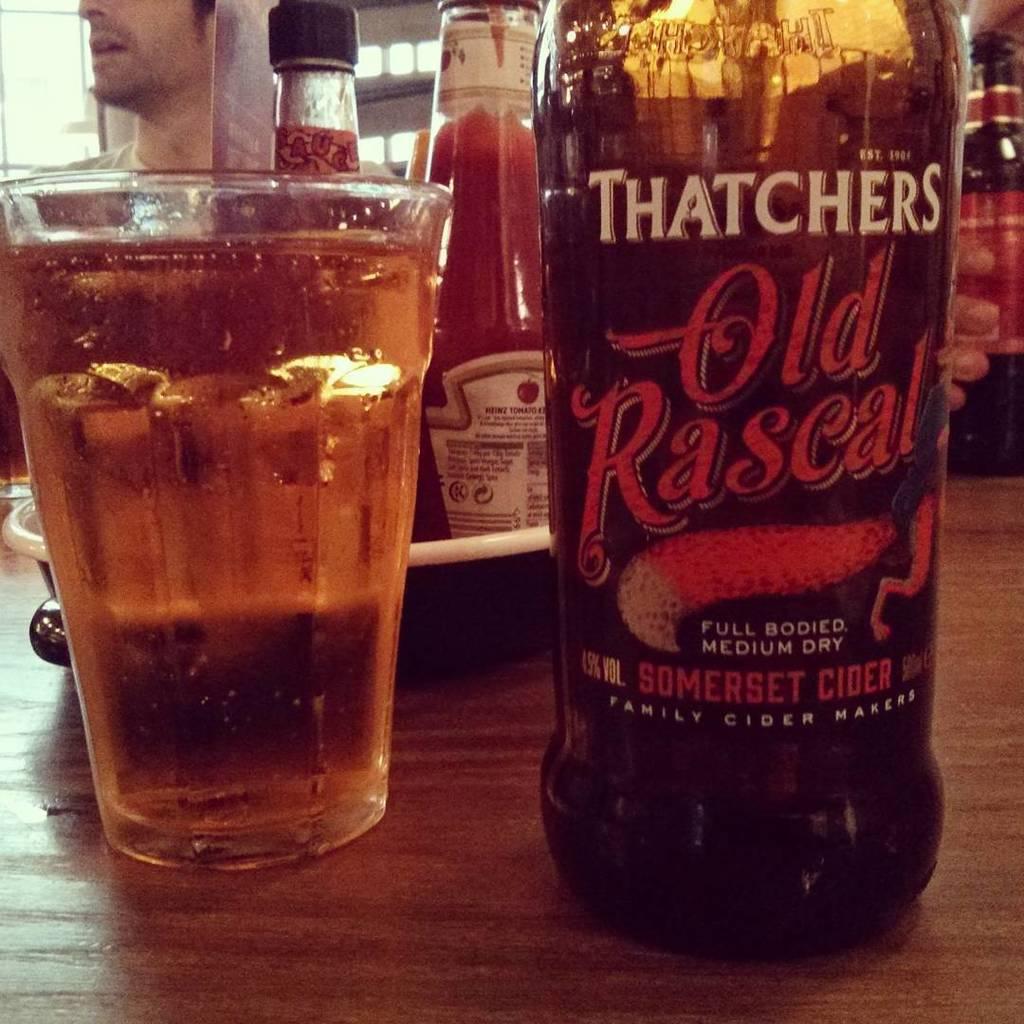This is a full bodied what?
Provide a succinct answer. Medium dry somerset cider. 